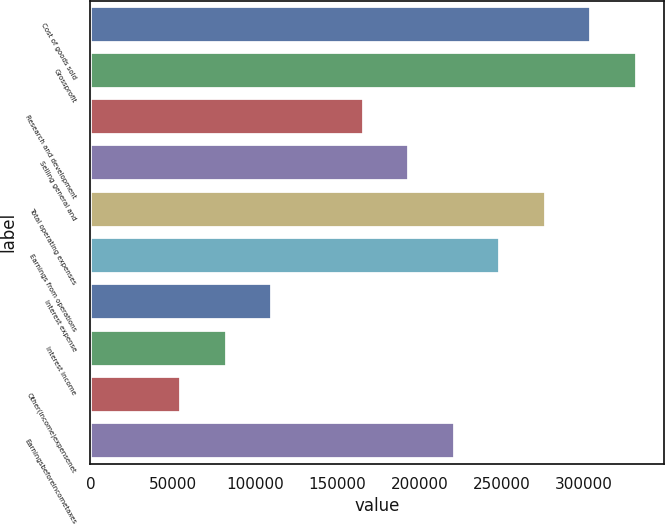Convert chart to OTSL. <chart><loc_0><loc_0><loc_500><loc_500><bar_chart><fcel>Cost of goods sold<fcel>Grossprofit<fcel>Research and development<fcel>Selling general and<fcel>Total operating expenses<fcel>Earnings from operations<fcel>Interest expense<fcel>Interest income<fcel>Other(income)expensenet<fcel>Earningsbeforeincometaxes<nl><fcel>304363<fcel>332033<fcel>166017<fcel>193686<fcel>276694<fcel>249025<fcel>110678<fcel>83009<fcel>55339.7<fcel>221355<nl></chart> 